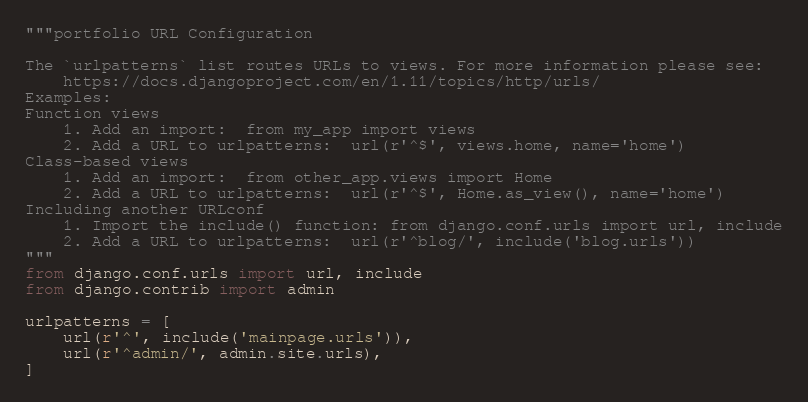Convert code to text. <code><loc_0><loc_0><loc_500><loc_500><_Python_>"""portfolio URL Configuration

The `urlpatterns` list routes URLs to views. For more information please see:
    https://docs.djangoproject.com/en/1.11/topics/http/urls/
Examples:
Function views
    1. Add an import:  from my_app import views
    2. Add a URL to urlpatterns:  url(r'^$', views.home, name='home')
Class-based views
    1. Add an import:  from other_app.views import Home
    2. Add a URL to urlpatterns:  url(r'^$', Home.as_view(), name='home')
Including another URLconf
    1. Import the include() function: from django.conf.urls import url, include
    2. Add a URL to urlpatterns:  url(r'^blog/', include('blog.urls'))
"""
from django.conf.urls import url, include
from django.contrib import admin

urlpatterns = [
    url(r'^', include('mainpage.urls')),
    url(r'^admin/', admin.site.urls),
]</code> 